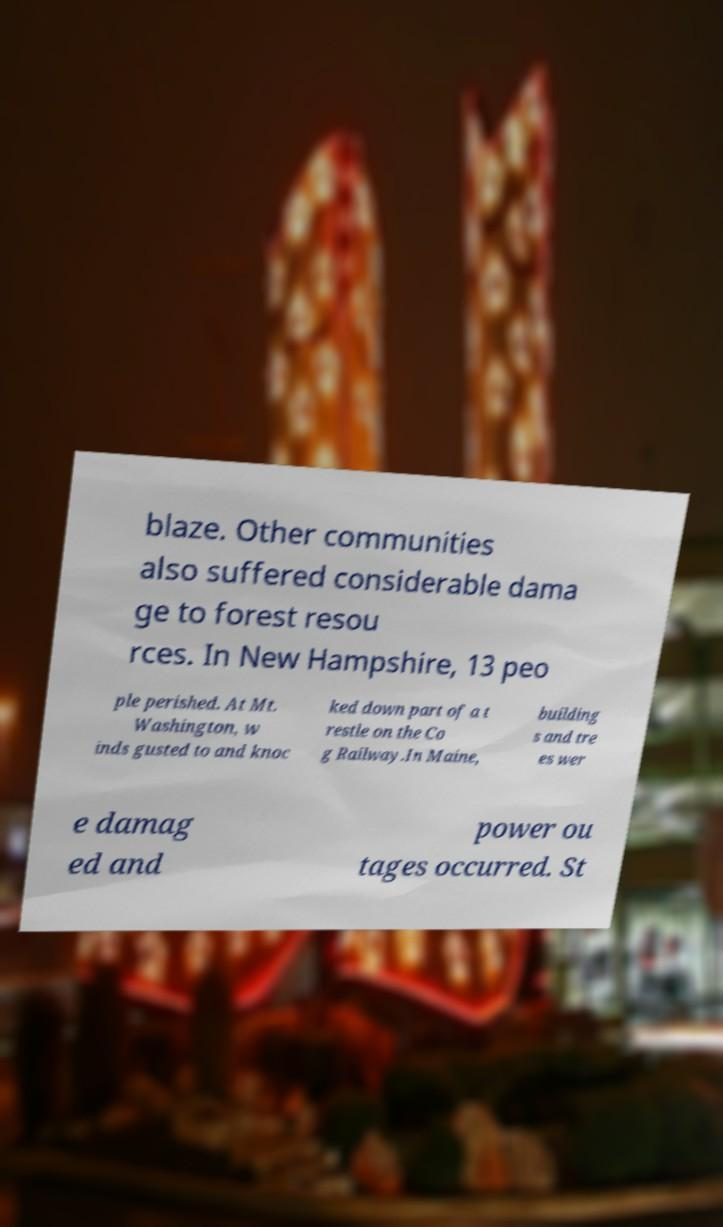What messages or text are displayed in this image? I need them in a readable, typed format. blaze. Other communities also suffered considerable dama ge to forest resou rces. In New Hampshire, 13 peo ple perished. At Mt. Washington, w inds gusted to and knoc ked down part of a t restle on the Co g Railway.In Maine, building s and tre es wer e damag ed and power ou tages occurred. St 